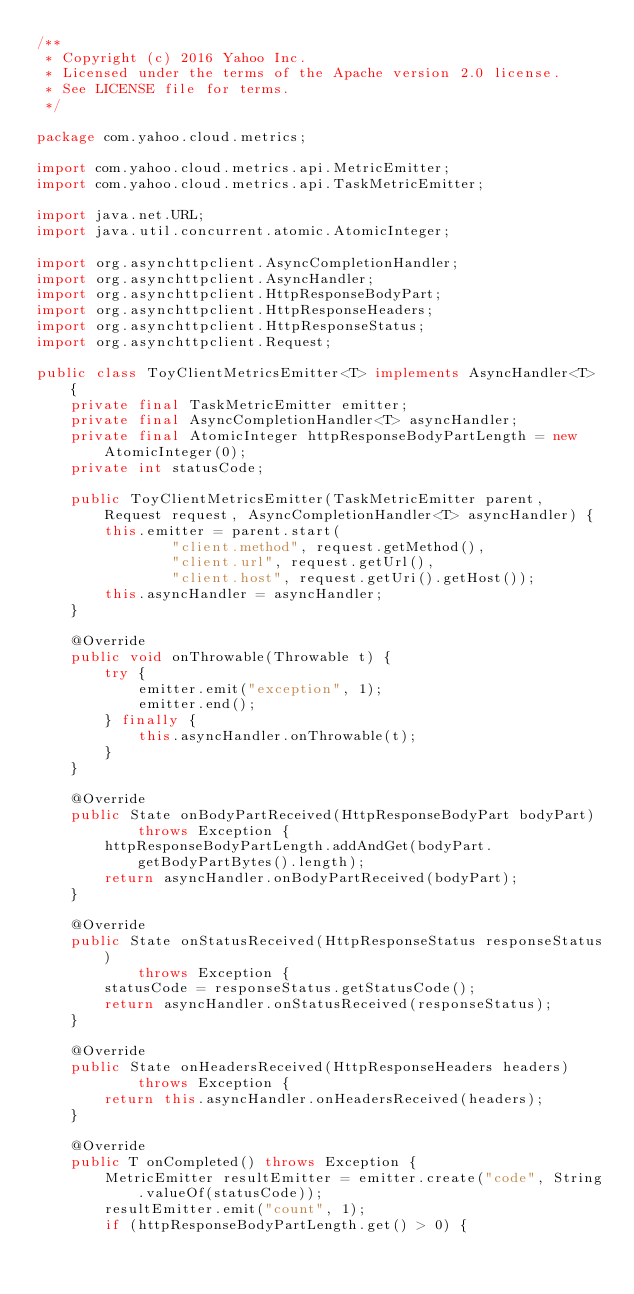Convert code to text. <code><loc_0><loc_0><loc_500><loc_500><_Java_>/**
 * Copyright (c) 2016 Yahoo Inc.
 * Licensed under the terms of the Apache version 2.0 license.
 * See LICENSE file for terms.
 */

package com.yahoo.cloud.metrics;

import com.yahoo.cloud.metrics.api.MetricEmitter;
import com.yahoo.cloud.metrics.api.TaskMetricEmitter;

import java.net.URL;
import java.util.concurrent.atomic.AtomicInteger;

import org.asynchttpclient.AsyncCompletionHandler;
import org.asynchttpclient.AsyncHandler;
import org.asynchttpclient.HttpResponseBodyPart;
import org.asynchttpclient.HttpResponseHeaders;
import org.asynchttpclient.HttpResponseStatus;
import org.asynchttpclient.Request;

public class ToyClientMetricsEmitter<T> implements AsyncHandler<T> {
    private final TaskMetricEmitter emitter;
    private final AsyncCompletionHandler<T> asyncHandler;
    private final AtomicInteger httpResponseBodyPartLength = new AtomicInteger(0);
    private int statusCode;

    public ToyClientMetricsEmitter(TaskMetricEmitter parent, Request request, AsyncCompletionHandler<T> asyncHandler) {
        this.emitter = parent.start(
                "client.method", request.getMethod(),
                "client.url", request.getUrl(),
                "client.host", request.getUri().getHost());
        this.asyncHandler = asyncHandler;
    }

    @Override
    public void onThrowable(Throwable t) {
        try {
            emitter.emit("exception", 1);
            emitter.end();
        } finally {
            this.asyncHandler.onThrowable(t);
        }
    }

    @Override
    public State onBodyPartReceived(HttpResponseBodyPart bodyPart)
            throws Exception {
        httpResponseBodyPartLength.addAndGet(bodyPart.getBodyPartBytes().length);
        return asyncHandler.onBodyPartReceived(bodyPart);
    }

    @Override
    public State onStatusReceived(HttpResponseStatus responseStatus)
            throws Exception {
        statusCode = responseStatus.getStatusCode();
        return asyncHandler.onStatusReceived(responseStatus);
    }

    @Override
    public State onHeadersReceived(HttpResponseHeaders headers)
            throws Exception {
        return this.asyncHandler.onHeadersReceived(headers);
    }

    @Override
    public T onCompleted() throws Exception {
        MetricEmitter resultEmitter = emitter.create("code", String.valueOf(statusCode));
        resultEmitter.emit("count", 1);
        if (httpResponseBodyPartLength.get() > 0) {</code> 